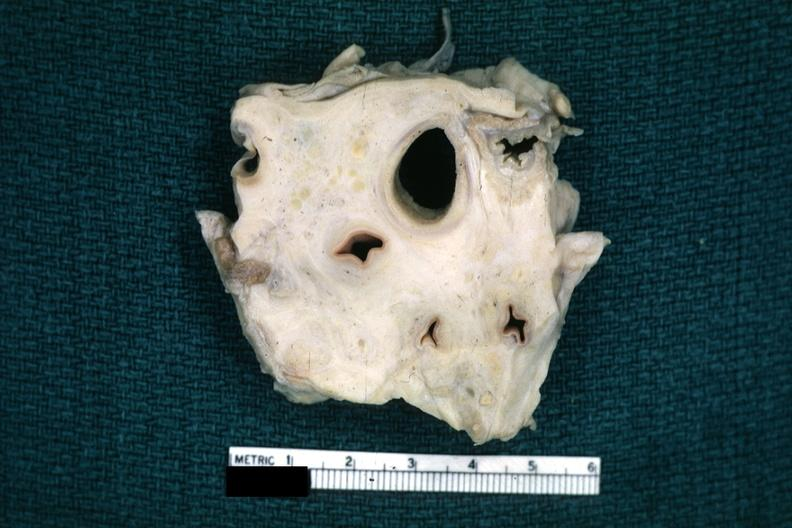does infant body show fixed tissue trachea and arteries surrounded by dense tumor tissue horizontal section?
Answer the question using a single word or phrase. No 